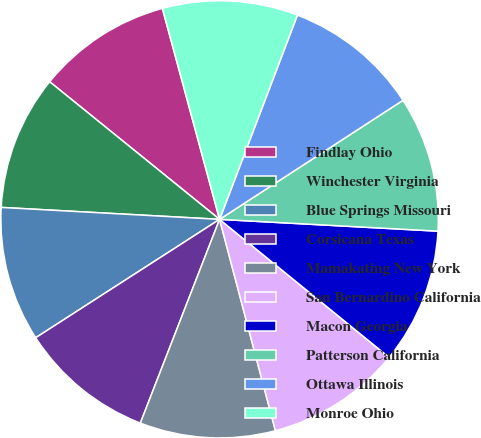Convert chart to OTSL. <chart><loc_0><loc_0><loc_500><loc_500><pie_chart><fcel>Findlay Ohio<fcel>Winchester Virginia<fcel>Blue Springs Missouri<fcel>Corsicana Texas<fcel>Mamakating New York<fcel>San Bernardino California<fcel>Macon Georgia<fcel>Patterson California<fcel>Ottawa Illinois<fcel>Monroe Ohio<nl><fcel>9.95%<fcel>9.97%<fcel>9.98%<fcel>9.99%<fcel>10.01%<fcel>10.01%<fcel>10.02%<fcel>10.03%<fcel>10.04%<fcel>10.0%<nl></chart> 